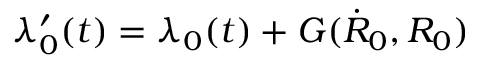Convert formula to latex. <formula><loc_0><loc_0><loc_500><loc_500>\lambda _ { 0 } ^ { \prime } ( t ) = \lambda _ { 0 } ( t ) + G ( \dot { R } _ { 0 } , R _ { 0 } )</formula> 